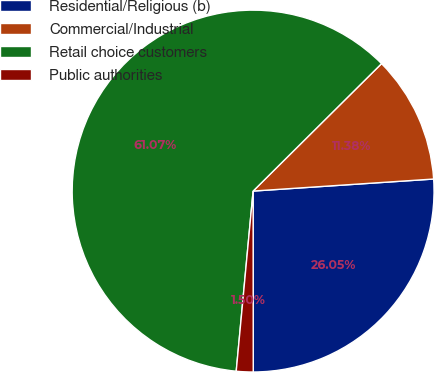Convert chart. <chart><loc_0><loc_0><loc_500><loc_500><pie_chart><fcel>Residential/Religious (b)<fcel>Commercial/Industrial<fcel>Retail choice customers<fcel>Public authorities<nl><fcel>26.05%<fcel>11.38%<fcel>61.08%<fcel>1.5%<nl></chart> 